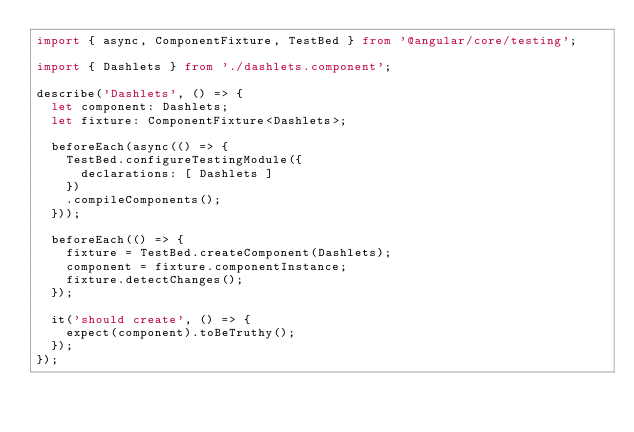Convert code to text. <code><loc_0><loc_0><loc_500><loc_500><_TypeScript_>import { async, ComponentFixture, TestBed } from '@angular/core/testing';

import { Dashlets } from './dashlets.component';

describe('Dashlets', () => {
  let component: Dashlets;
  let fixture: ComponentFixture<Dashlets>;

  beforeEach(async(() => {
    TestBed.configureTestingModule({
      declarations: [ Dashlets ]
    })
    .compileComponents();
  }));

  beforeEach(() => {
    fixture = TestBed.createComponent(Dashlets);
    component = fixture.componentInstance;
    fixture.detectChanges();
  });

  it('should create', () => {
    expect(component).toBeTruthy();
  });
});
</code> 